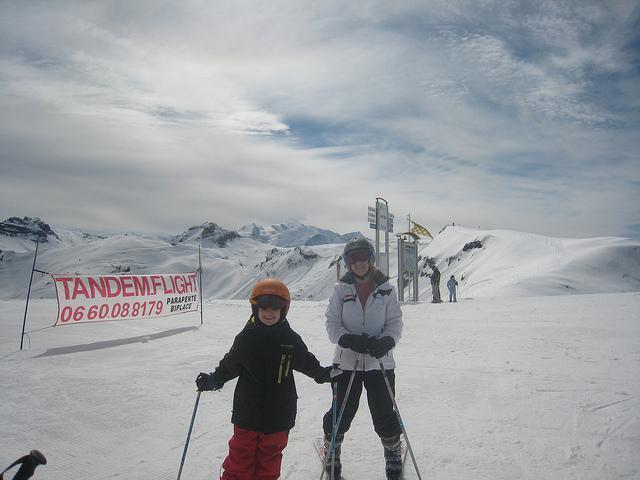How many people?
Give a very brief answer. 4. How many people are wearing their goggles?
Give a very brief answer. 2. How many people are in the picture?
Give a very brief answer. 2. How many dogs are there?
Give a very brief answer. 0. 